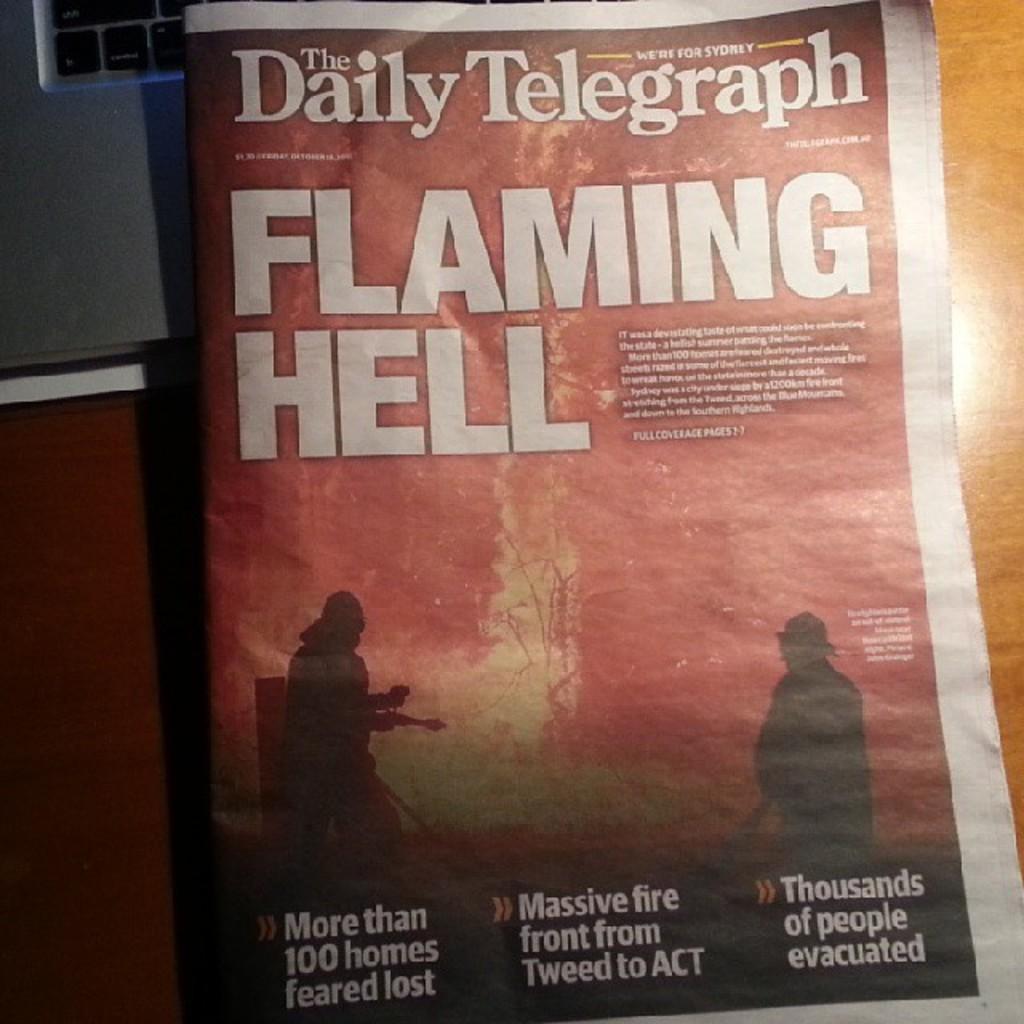What is the name of this newspaper?
Provide a succinct answer. The daily telegraph. Its magazine book?
Offer a very short reply. Yes. 